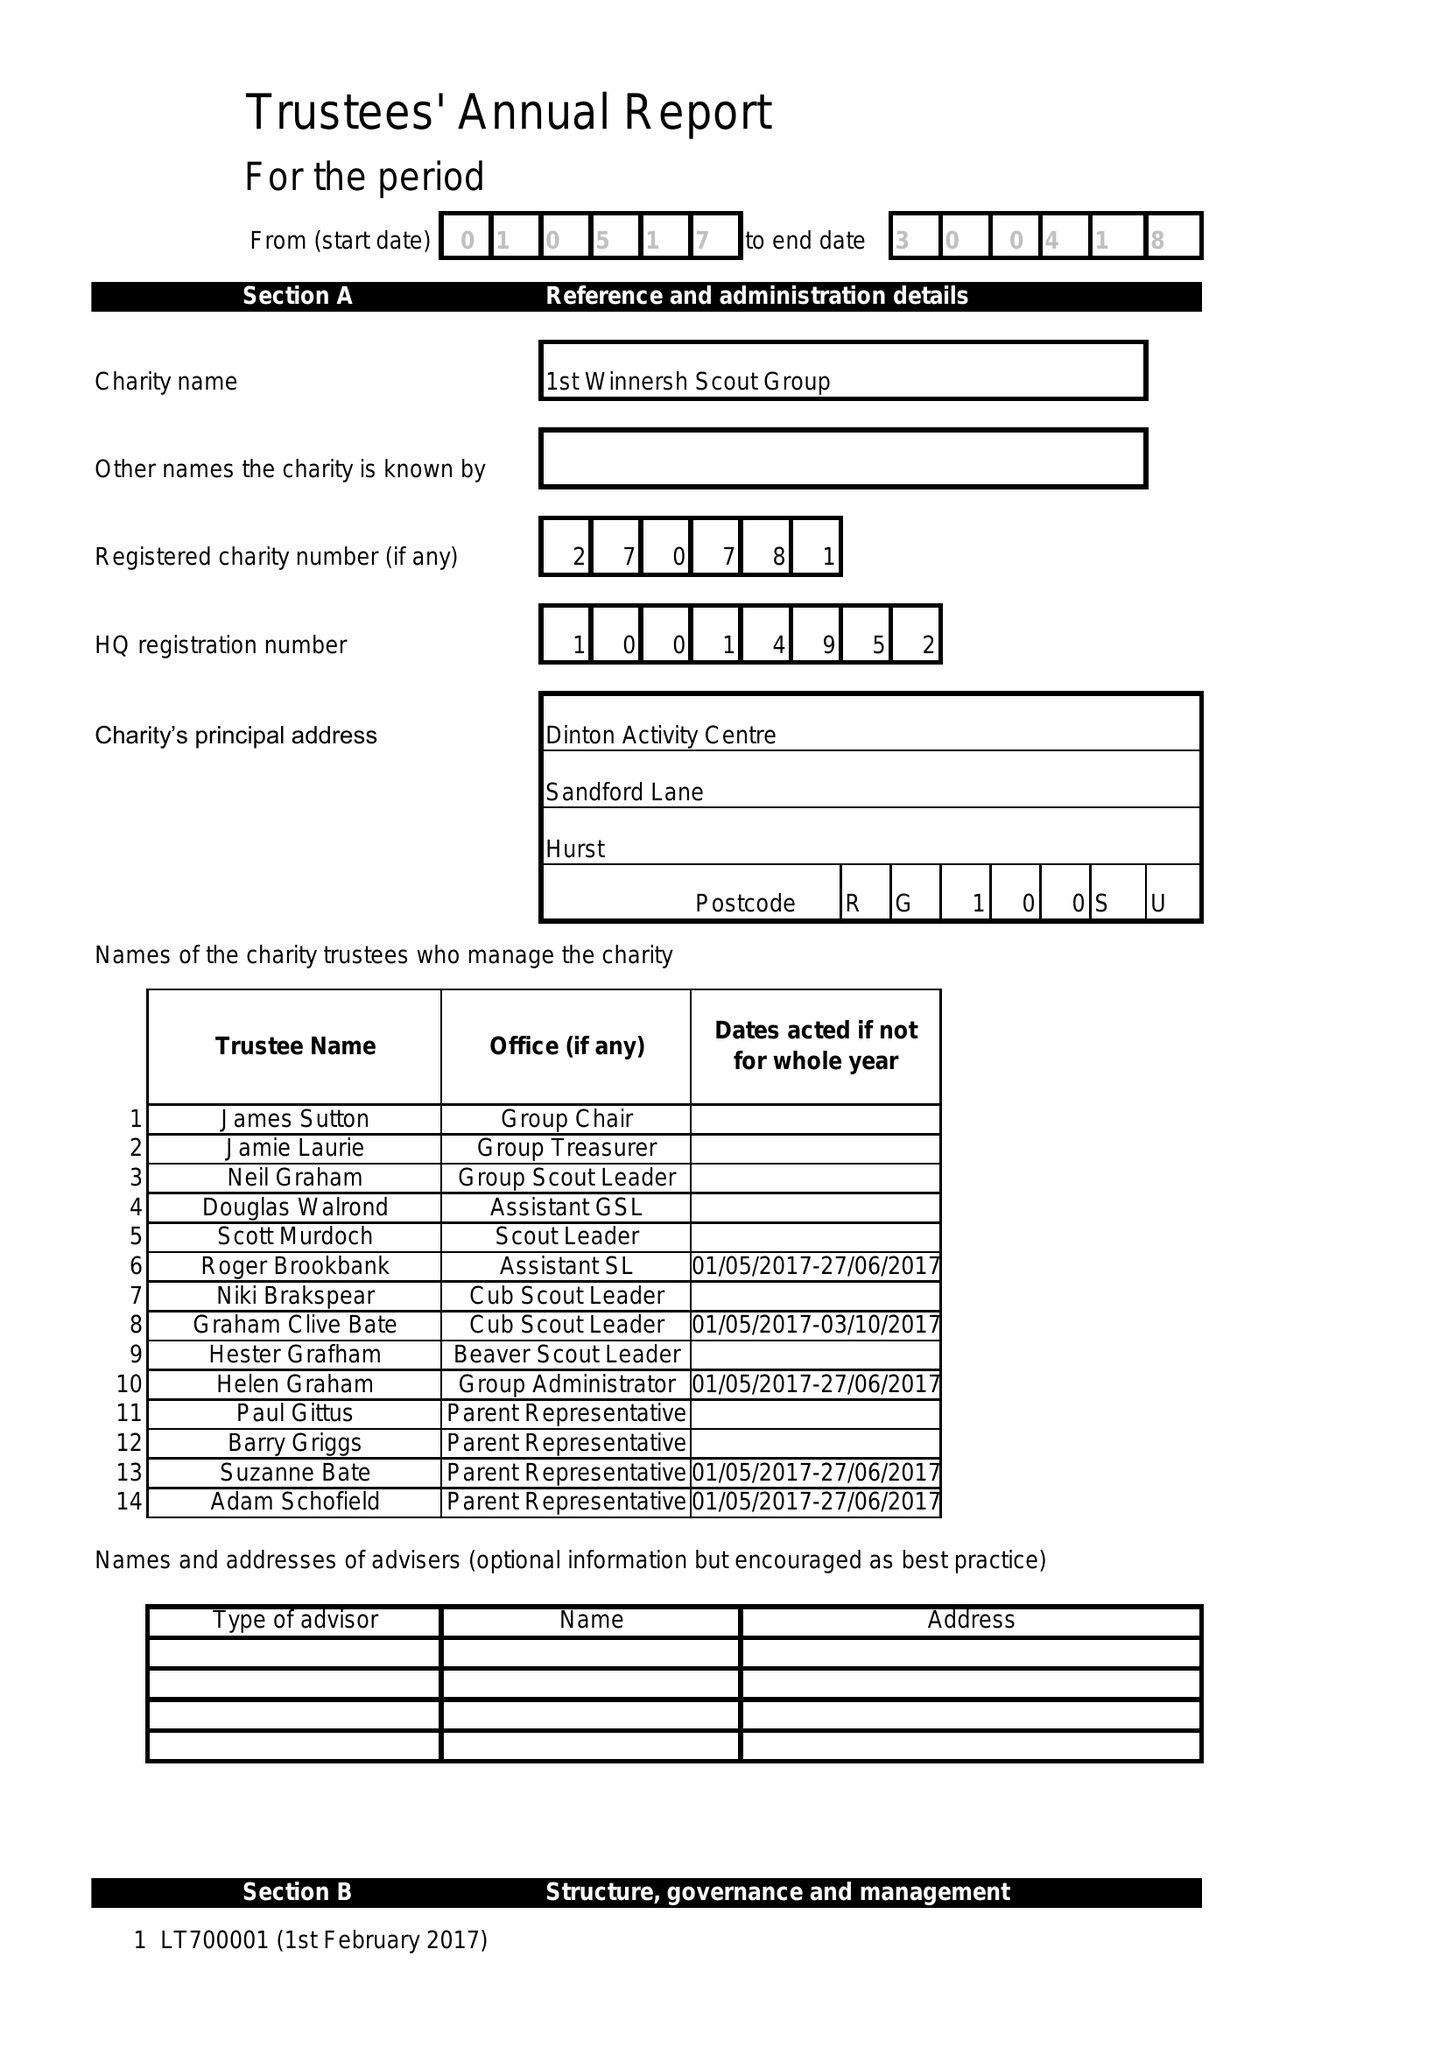What is the value for the address__post_town?
Answer the question using a single word or phrase. READING 